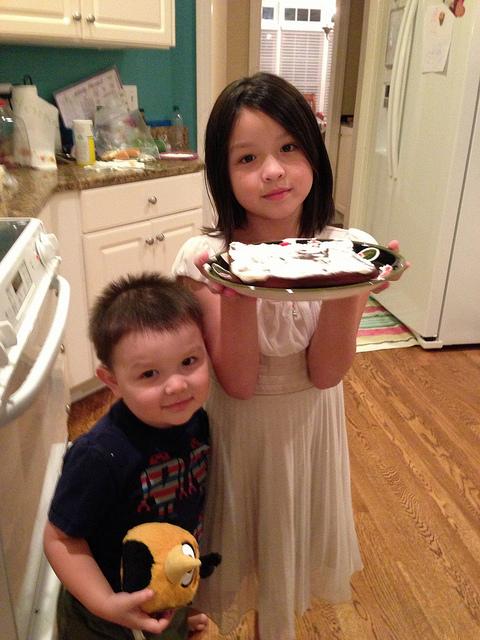Is everyone standing in this picture?
Keep it brief. Yes. Who is older the girl or the boy?
Write a very short answer. Girl. What is the boy holding?
Keep it brief. Angry bird. Which child holds a stuffed toy?
Answer briefly. Boy. 